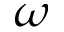Convert formula to latex. <formula><loc_0><loc_0><loc_500><loc_500>\omega</formula> 